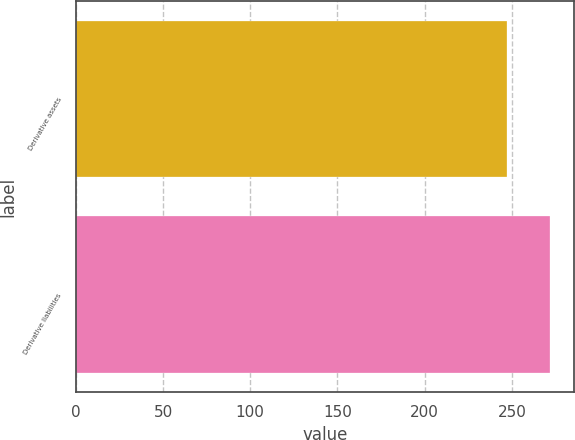Convert chart to OTSL. <chart><loc_0><loc_0><loc_500><loc_500><bar_chart><fcel>Derivative assets<fcel>Derivative liabilities<nl><fcel>247<fcel>272<nl></chart> 